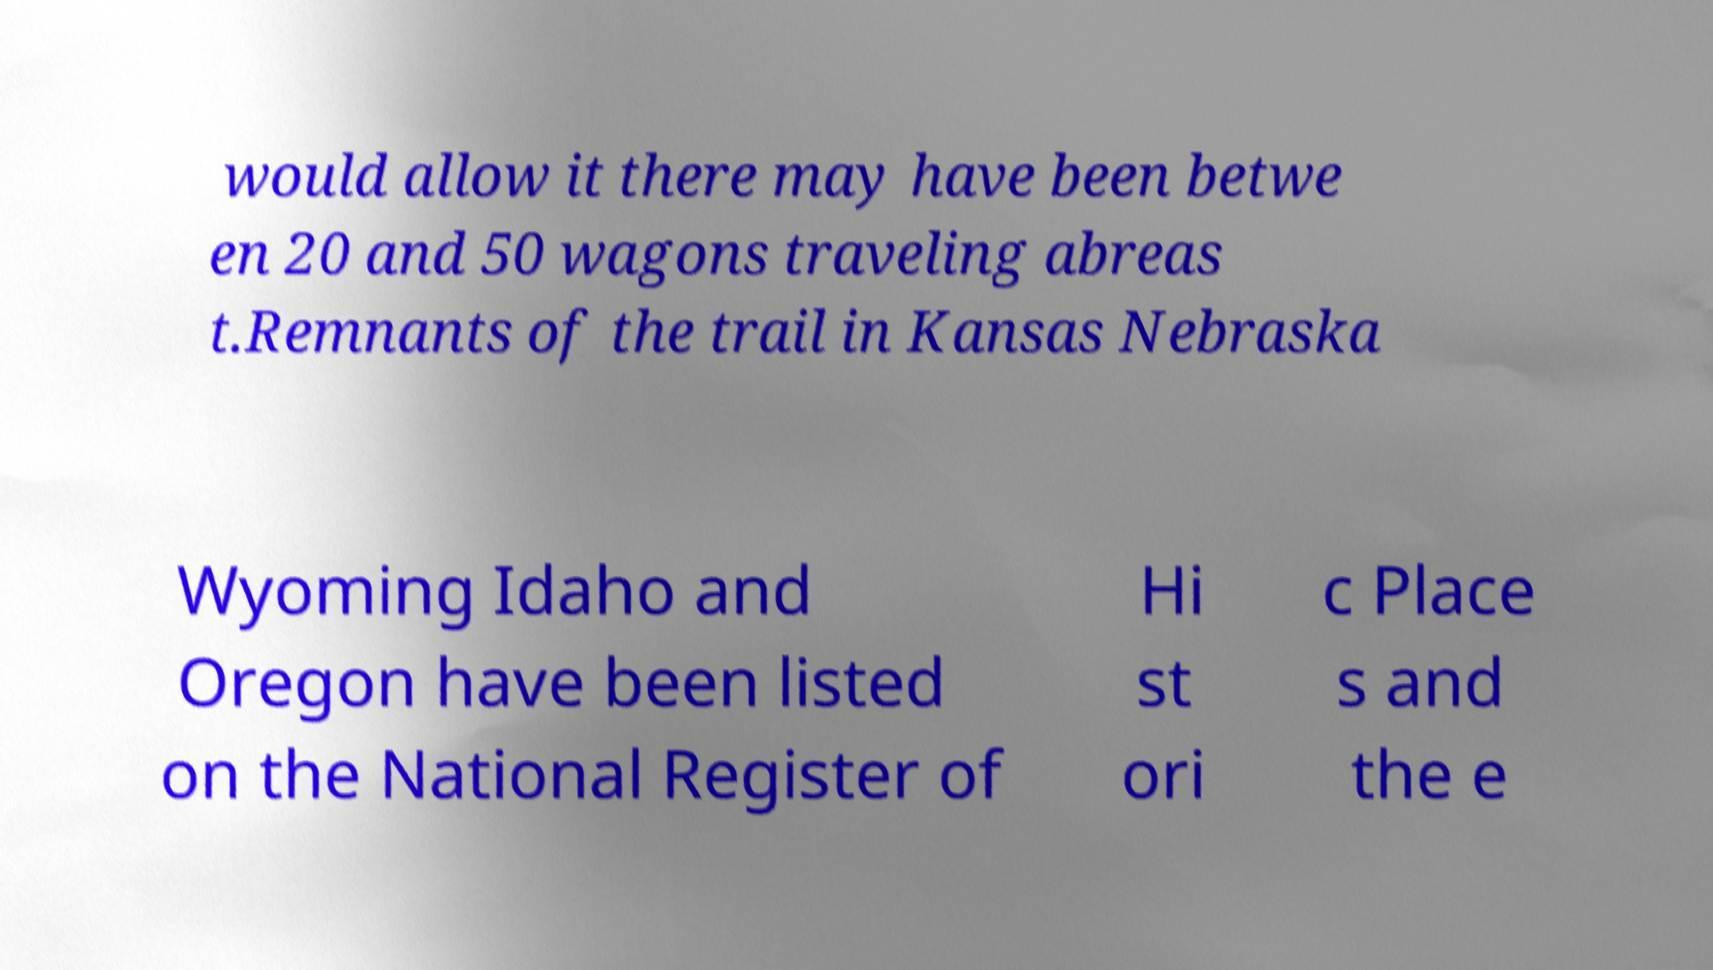For documentation purposes, I need the text within this image transcribed. Could you provide that? would allow it there may have been betwe en 20 and 50 wagons traveling abreas t.Remnants of the trail in Kansas Nebraska Wyoming Idaho and Oregon have been listed on the National Register of Hi st ori c Place s and the e 